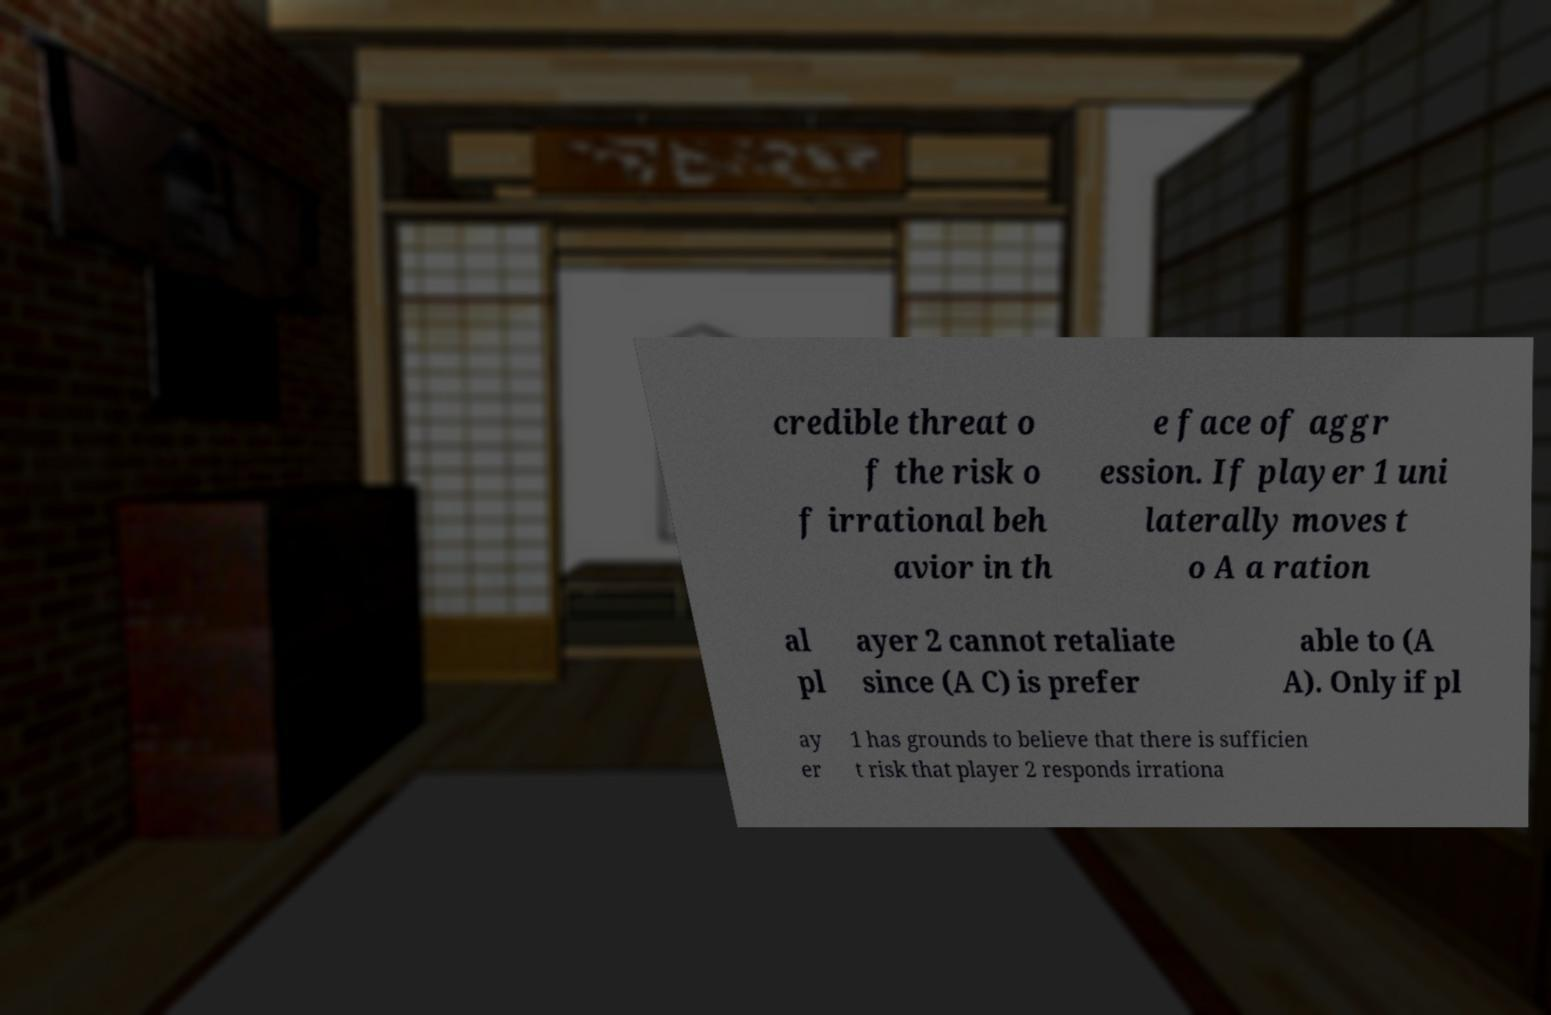Could you assist in decoding the text presented in this image and type it out clearly? credible threat o f the risk o f irrational beh avior in th e face of aggr ession. If player 1 uni laterally moves t o A a ration al pl ayer 2 cannot retaliate since (A C) is prefer able to (A A). Only if pl ay er 1 has grounds to believe that there is sufficien t risk that player 2 responds irrationa 